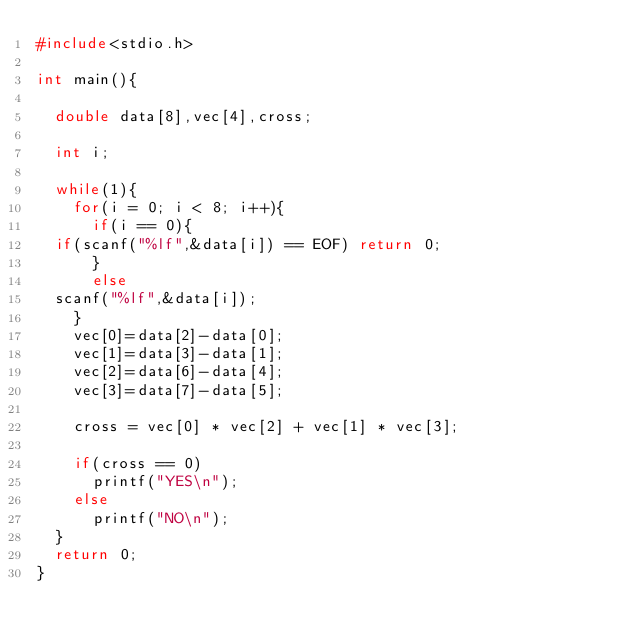Convert code to text. <code><loc_0><loc_0><loc_500><loc_500><_C_>#include<stdio.h>

int main(){
  
  double data[8],vec[4],cross;

  int i;

  while(1){
    for(i = 0; i < 8; i++){
      if(i == 0){
	if(scanf("%lf",&data[i]) == EOF) return 0;
      }
      else
	scanf("%lf",&data[i]);
    }
    vec[0]=data[2]-data[0];
    vec[1]=data[3]-data[1];
    vec[2]=data[6]-data[4];
    vec[3]=data[7]-data[5];
    
    cross = vec[0] * vec[2] + vec[1] * vec[3];
    
    if(cross == 0)
      printf("YES\n");
    else
      printf("NO\n");
  }
  return 0;
}</code> 